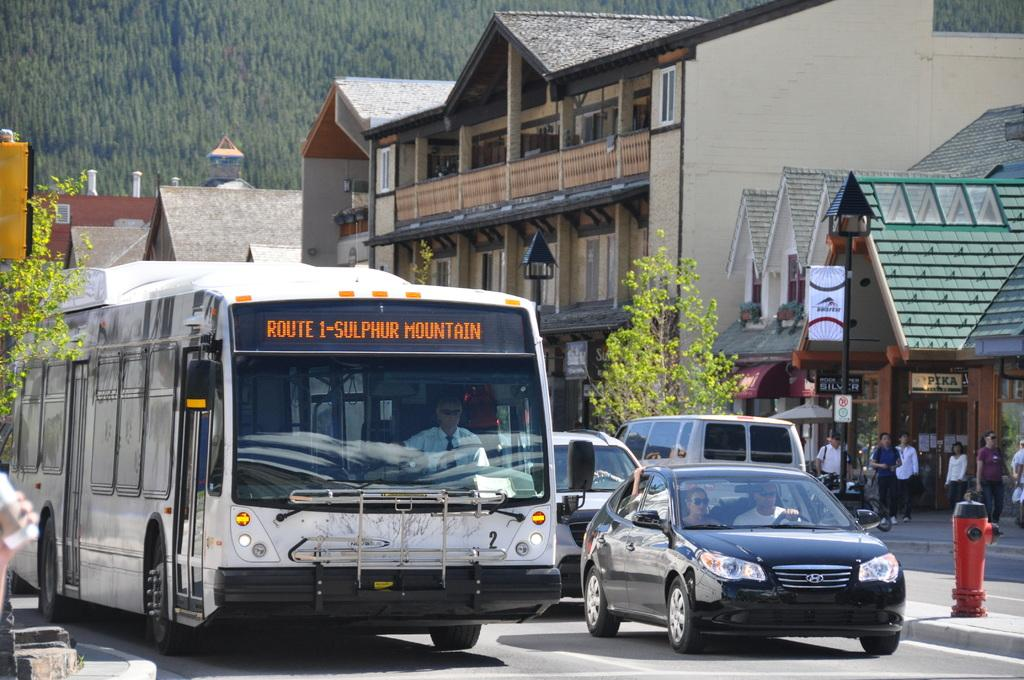What can be seen on the road in the image? There are vehicles on the road in the image. What else can be seen near the road in the image? There are people beside the road in the image. What type of establishments are present in the image? There are stores in the image. What structures are visible in the image? There are buildings in the image. What can be seen in the distance in the image? There are many trees in the background of the image. How many chairs are visible in the image? There are no chairs visible in the image. 